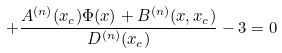Convert formula to latex. <formula><loc_0><loc_0><loc_500><loc_500>+ \frac { A ^ { ( n ) } ( x _ { c } ) \Phi ( x ) + B ^ { ( n ) } ( x , x _ { c } ) } { D ^ { ( n ) } ( x _ { c } ) } - 3 = 0</formula> 